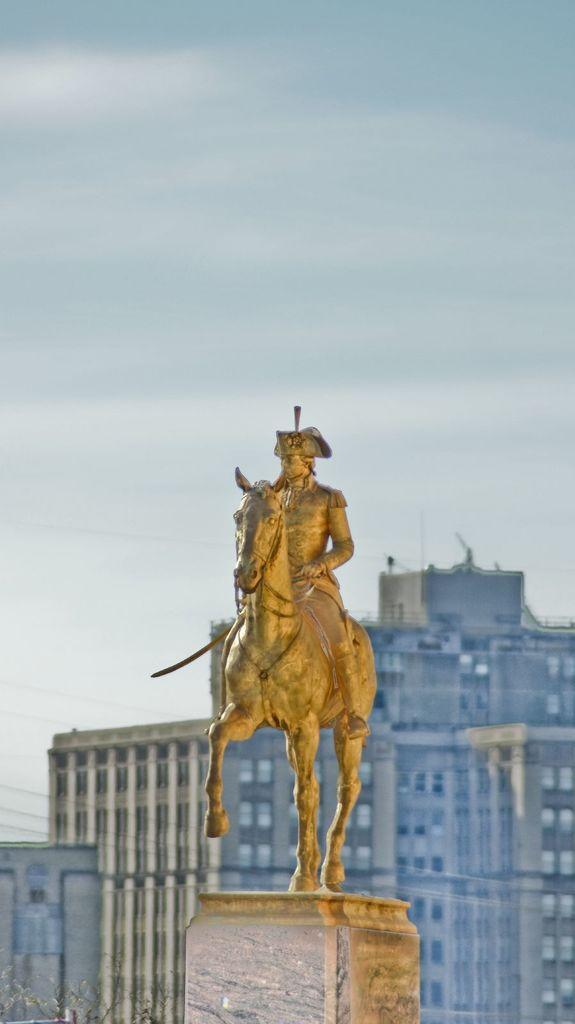Can you describe this image briefly? In this image we can see a statue of a person sitting on a horse, behind the statue there are buildings. 